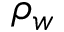Convert formula to latex. <formula><loc_0><loc_0><loc_500><loc_500>\rho _ { w }</formula> 